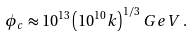<formula> <loc_0><loc_0><loc_500><loc_500>\phi _ { c } \approx 1 0 ^ { 1 3 } \left ( 1 0 ^ { 1 0 } k \right ) ^ { 1 / 3 } \, G e V \, .</formula> 